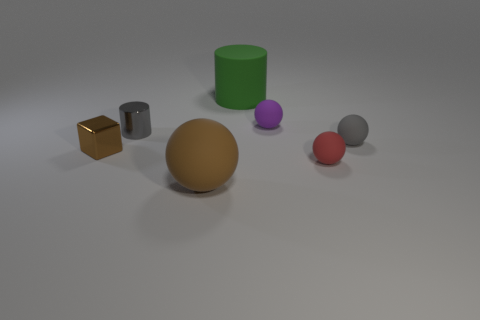Subtract all gray blocks. Subtract all gray cylinders. How many blocks are left? 1 Add 2 cyan matte cubes. How many objects exist? 9 Subtract all cylinders. How many objects are left? 5 Subtract 0 blue blocks. How many objects are left? 7 Subtract all green objects. Subtract all spheres. How many objects are left? 2 Add 3 shiny cubes. How many shiny cubes are left? 4 Add 5 tiny matte objects. How many tiny matte objects exist? 8 